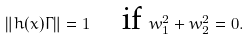Convert formula to latex. <formula><loc_0><loc_0><loc_500><loc_500>\| h ( x ) \Gamma \| = 1 \quad \text {if } w _ { 1 } ^ { 2 } + w _ { 2 } ^ { 2 } = 0 .</formula> 